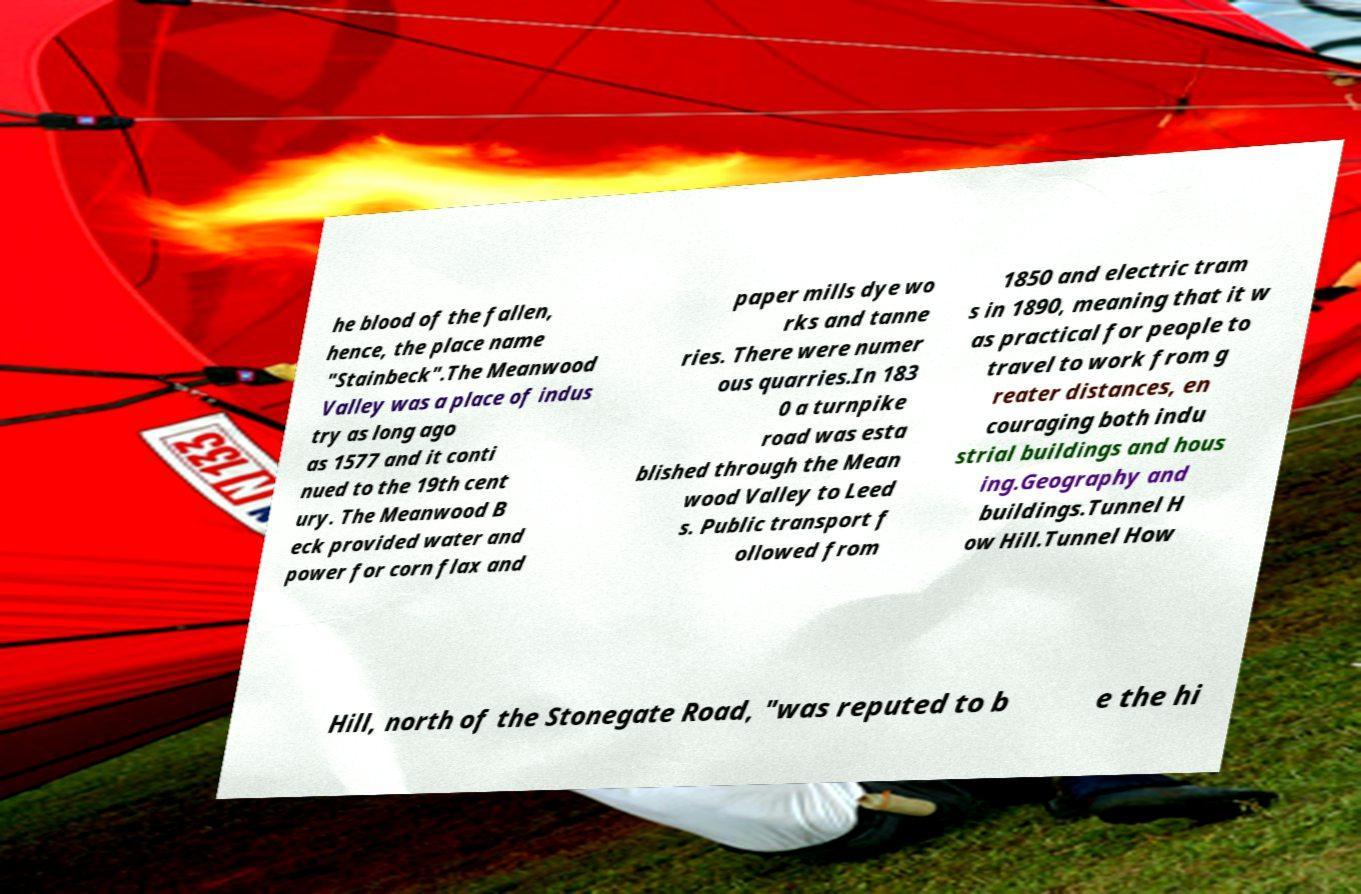Can you accurately transcribe the text from the provided image for me? he blood of the fallen, hence, the place name "Stainbeck".The Meanwood Valley was a place of indus try as long ago as 1577 and it conti nued to the 19th cent ury. The Meanwood B eck provided water and power for corn flax and paper mills dye wo rks and tanne ries. There were numer ous quarries.In 183 0 a turnpike road was esta blished through the Mean wood Valley to Leed s. Public transport f ollowed from 1850 and electric tram s in 1890, meaning that it w as practical for people to travel to work from g reater distances, en couraging both indu strial buildings and hous ing.Geography and buildings.Tunnel H ow Hill.Tunnel How Hill, north of the Stonegate Road, "was reputed to b e the hi 